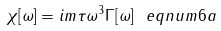<formula> <loc_0><loc_0><loc_500><loc_500>\chi [ \omega ] = i m \tau \omega ^ { 3 } \Gamma [ \omega ] \ e q n u m { 6 a }</formula> 